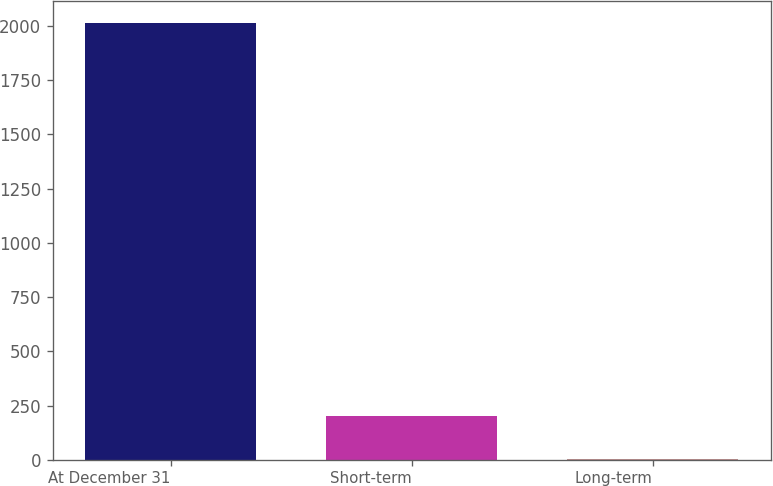Convert chart. <chart><loc_0><loc_0><loc_500><loc_500><bar_chart><fcel>At December 31<fcel>Short-term<fcel>Long-term<nl><fcel>2012<fcel>204.04<fcel>3.16<nl></chart> 